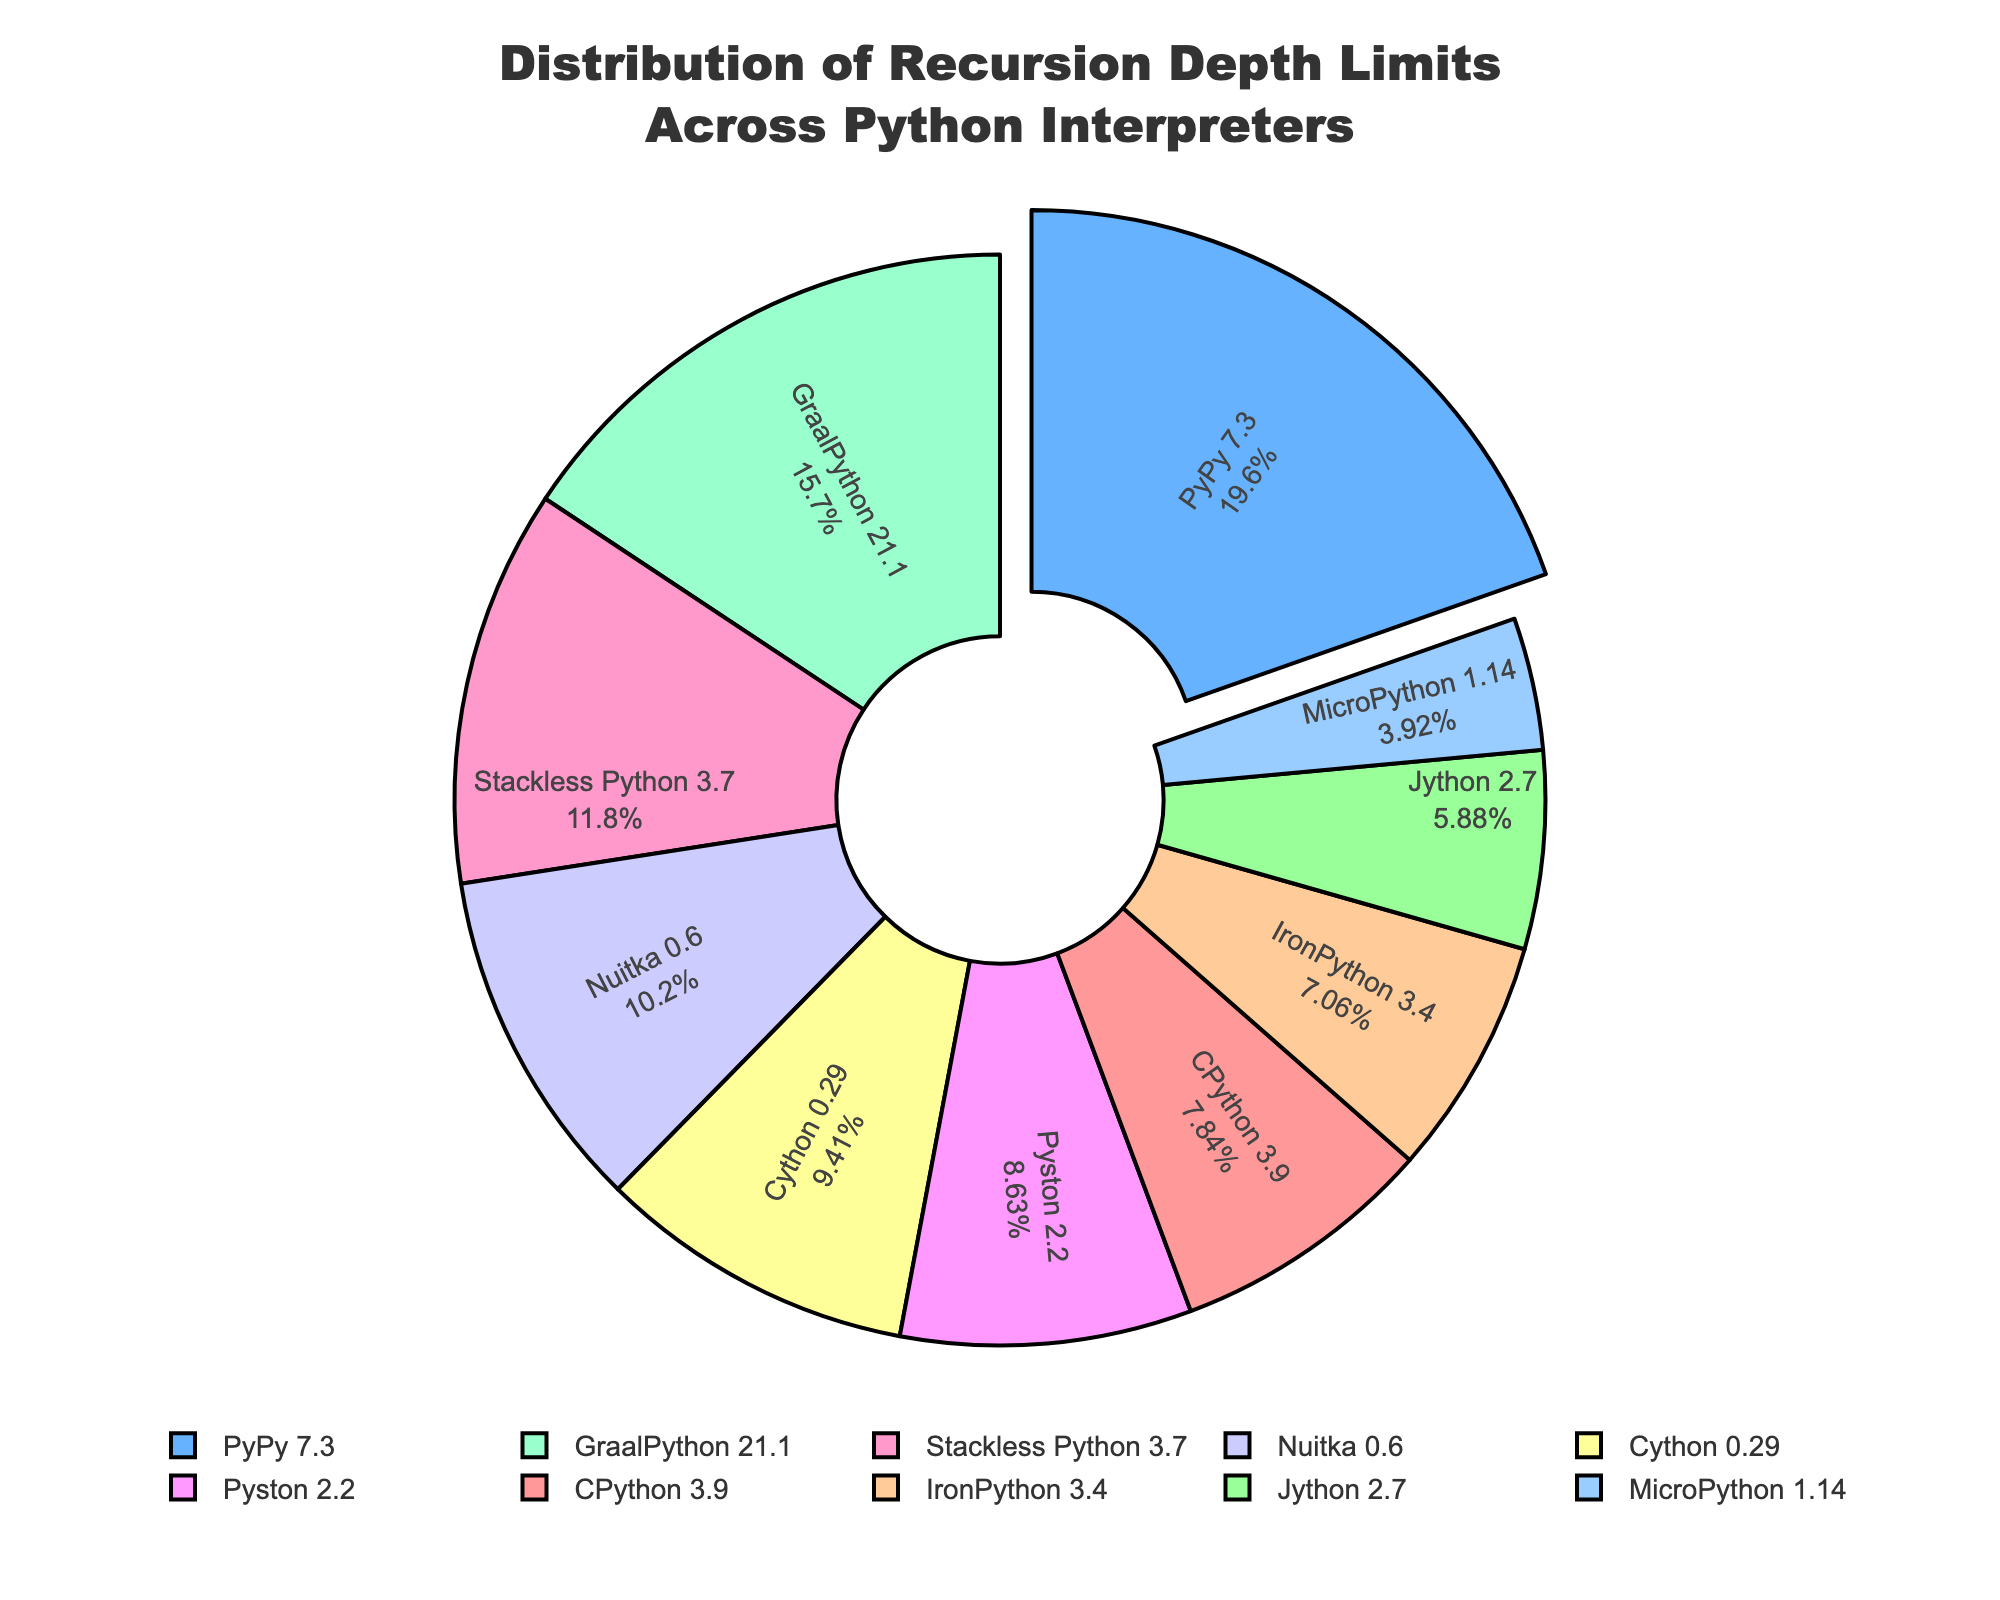Which Python interpreter has the highest recursion depth limit? The pie chart highlights the interpreter with the highest recursion depth limit through a slice pulled away from the rest, identified by its label, which shows both the interpreter name and the percentage of the total recursion depth.
Answer: PyPy 7.3 Which two Python interpreters have the lowest recursion depth limits and what are their respective limits? By looking at the slices of the pie chart, the smallest ones indicate the lowest recursion depth limits. These are identified by their labels, which include their interpreter names and depth limits.
Answer: MicroPython 1.14: 500, Jython 2.7: 750 What is the combined recursion depth limit of CPython 3.9, Stackless Python 3.7, and Cython 0.29? Locate the slices for CPython 3.9, Stackless Python 3.7, and Cython 0.29 on the pie chart. Sum their recursion depth limits shown in the labels.
Answer: 3700 What is the difference in recursion depth limit between GraalPython 21.1 and IronPython 3.4? Find the slices for GraalPython 21.1 and IronPython 3.4, then subtract the recursion depth limit of IronPython 3.4 from GraalPython 21.1.
Answer: 1100 Which interpreter has a recursion depth limit closest to the average recursion depth limit across all interpreters? Calculate the average recursion depth by summing all recursion depth limits and dividing by the total number of interpreters. Compare each interpreter's limit to this average and find the closest one.
Answer: Cython 0.29 How much larger is the recursion depth limit of Nuitka 0.6 compared to MicroPython 1.14? Locate the slices for Nuitka 0.6 and MicroPython 1.14 and subtract the recursion depth of MicroPython 1.14 from that of Nuitka 0.6.
Answer: 800 Arrange the top three interpreters by their recursion depth limits in descending order. Identify the three slices with the highest values, which are PyPy 7.3, GraalPython 21.1, and Stackless Python 3.7, and list them from highest to lowest recursion depth.
Answer: PyPy 7.3, GraalPython 21.1, Stackless Python 3.7 How many interpreters have a recursion depth limit above 1000? Count the slices with recursion depth limits greater than 1000.
Answer: 5 Which color represents the recursion depth limit of IronPython 3.4 in the pie chart? Look at the slice labeled IronPython 3.4 and note the color used for this slice in the pie chart.
Answer: Light orange (approx.) If the recursion depth limits of all interpreters except PyPy 7.3 were doubled, which interpreter would have the highest limit then? Double the recursion depth limits for all interpreters except PyPy 7.3. Compare these new values to find the highest limit.
Answer: GraalPython 21.1 